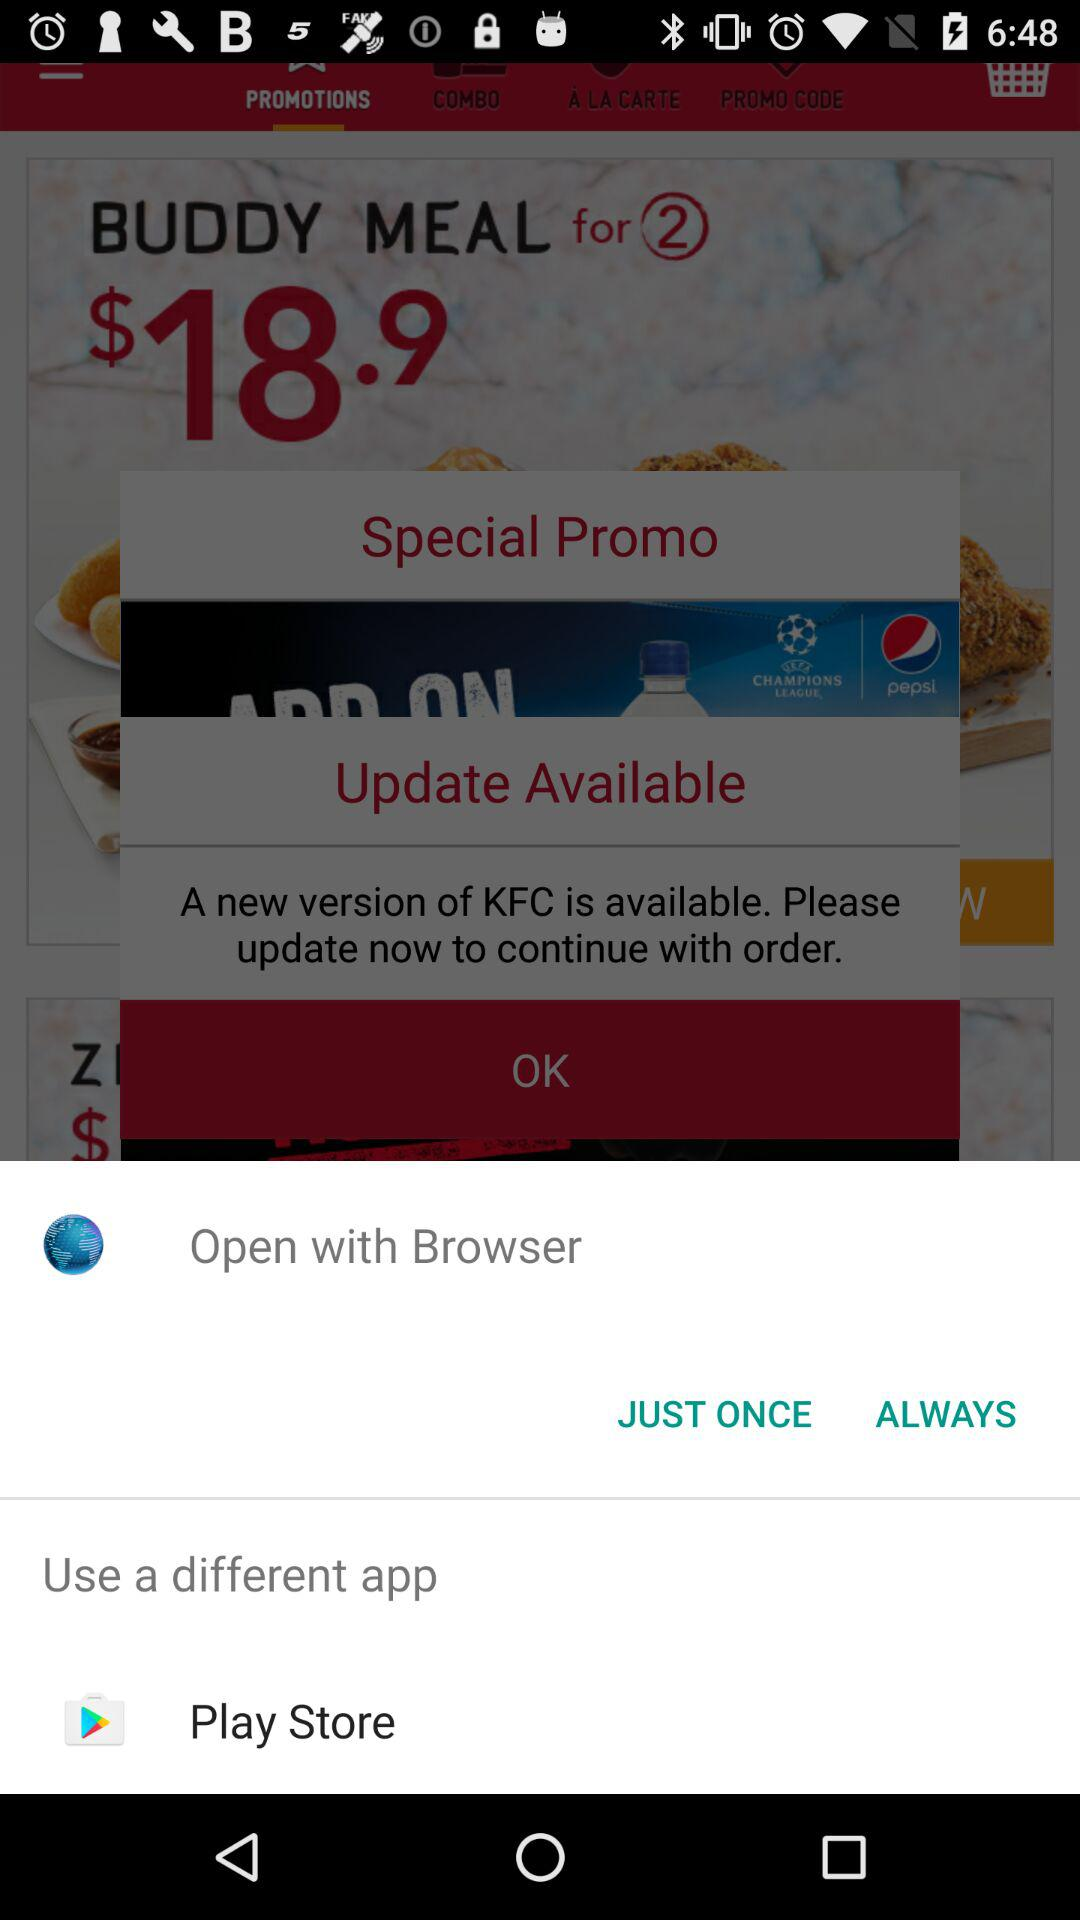What different app can be used to open the "KFC" app? The different app that can be used is "Play Store". 